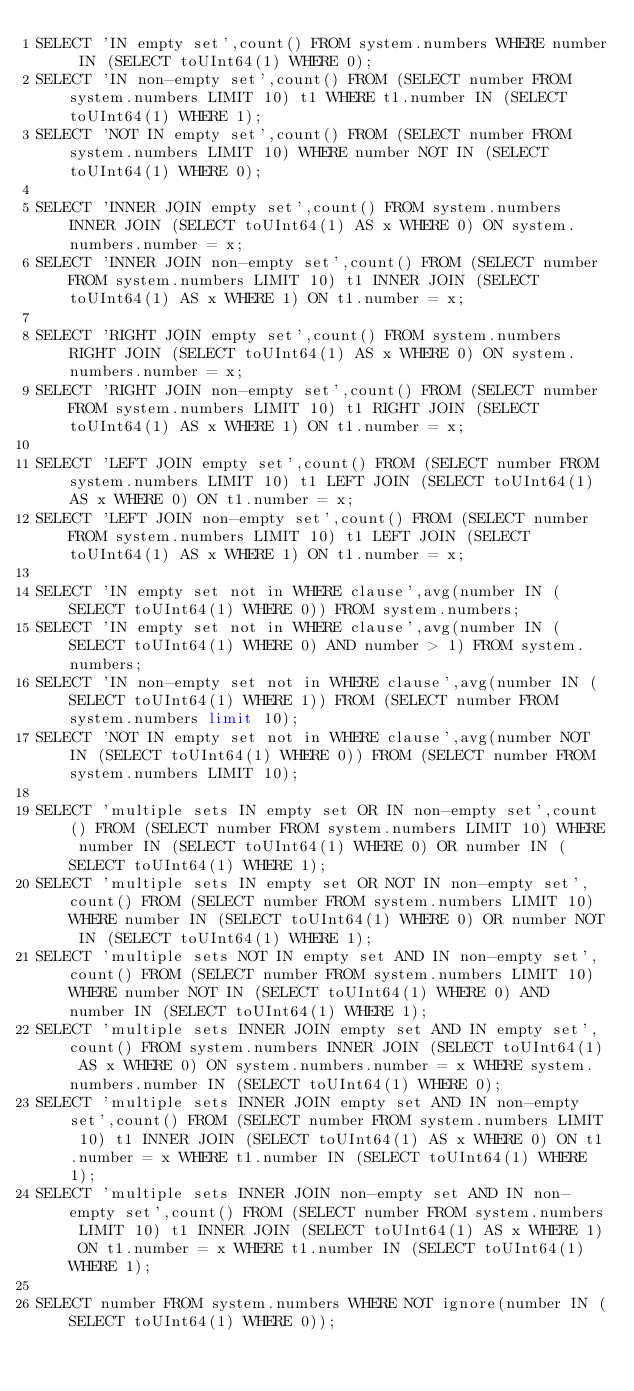<code> <loc_0><loc_0><loc_500><loc_500><_SQL_>SELECT 'IN empty set',count() FROM system.numbers WHERE number IN (SELECT toUInt64(1) WHERE 0);
SELECT 'IN non-empty set',count() FROM (SELECT number FROM system.numbers LIMIT 10) t1 WHERE t1.number IN (SELECT toUInt64(1) WHERE 1);
SELECT 'NOT IN empty set',count() FROM (SELECT number FROM system.numbers LIMIT 10) WHERE number NOT IN (SELECT toUInt64(1) WHERE 0);

SELECT 'INNER JOIN empty set',count() FROM system.numbers INNER JOIN (SELECT toUInt64(1) AS x WHERE 0) ON system.numbers.number = x;
SELECT 'INNER JOIN non-empty set',count() FROM (SELECT number FROM system.numbers LIMIT 10) t1 INNER JOIN (SELECT toUInt64(1) AS x WHERE 1) ON t1.number = x;

SELECT 'RIGHT JOIN empty set',count() FROM system.numbers RIGHT JOIN (SELECT toUInt64(1) AS x WHERE 0) ON system.numbers.number = x;
SELECT 'RIGHT JOIN non-empty set',count() FROM (SELECT number FROM system.numbers LIMIT 10) t1 RIGHT JOIN (SELECT toUInt64(1) AS x WHERE 1) ON t1.number = x;

SELECT 'LEFT JOIN empty set',count() FROM (SELECT number FROM system.numbers LIMIT 10) t1 LEFT JOIN (SELECT toUInt64(1) AS x WHERE 0) ON t1.number = x;
SELECT 'LEFT JOIN non-empty set',count() FROM (SELECT number FROM system.numbers LIMIT 10) t1 LEFT JOIN (SELECT toUInt64(1) AS x WHERE 1) ON t1.number = x;

SELECT 'IN empty set not in WHERE clause',avg(number IN (SELECT toUInt64(1) WHERE 0)) FROM system.numbers;
SELECT 'IN empty set not in WHERE clause',avg(number IN (SELECT toUInt64(1) WHERE 0) AND number > 1) FROM system.numbers;
SELECT 'IN non-empty set not in WHERE clause',avg(number IN (SELECT toUInt64(1) WHERE 1)) FROM (SELECT number FROM system.numbers limit 10);
SELECT 'NOT IN empty set not in WHERE clause',avg(number NOT IN (SELECT toUInt64(1) WHERE 0)) FROM (SELECT number FROM system.numbers LIMIT 10);

SELECT 'multiple sets IN empty set OR IN non-empty set',count() FROM (SELECT number FROM system.numbers LIMIT 10) WHERE number IN (SELECT toUInt64(1) WHERE 0) OR number IN (SELECT toUInt64(1) WHERE 1);
SELECT 'multiple sets IN empty set OR NOT IN non-empty set',count() FROM (SELECT number FROM system.numbers LIMIT 10) WHERE number IN (SELECT toUInt64(1) WHERE 0) OR number NOT IN (SELECT toUInt64(1) WHERE 1);
SELECT 'multiple sets NOT IN empty set AND IN non-empty set',count() FROM (SELECT number FROM system.numbers LIMIT 10) WHERE number NOT IN (SELECT toUInt64(1) WHERE 0) AND number IN (SELECT toUInt64(1) WHERE 1);
SELECT 'multiple sets INNER JOIN empty set AND IN empty set',count() FROM system.numbers INNER JOIN (SELECT toUInt64(1) AS x WHERE 0) ON system.numbers.number = x WHERE system.numbers.number IN (SELECT toUInt64(1) WHERE 0);
SELECT 'multiple sets INNER JOIN empty set AND IN non-empty set',count() FROM (SELECT number FROM system.numbers LIMIT 10) t1 INNER JOIN (SELECT toUInt64(1) AS x WHERE 0) ON t1.number = x WHERE t1.number IN (SELECT toUInt64(1) WHERE 1);
SELECT 'multiple sets INNER JOIN non-empty set AND IN non-empty set',count() FROM (SELECT number FROM system.numbers LIMIT 10) t1 INNER JOIN (SELECT toUInt64(1) AS x WHERE 1) ON t1.number = x WHERE t1.number IN (SELECT toUInt64(1) WHERE 1);

SELECT number FROM system.numbers WHERE NOT ignore(number IN (SELECT toUInt64(1) WHERE 0));
</code> 